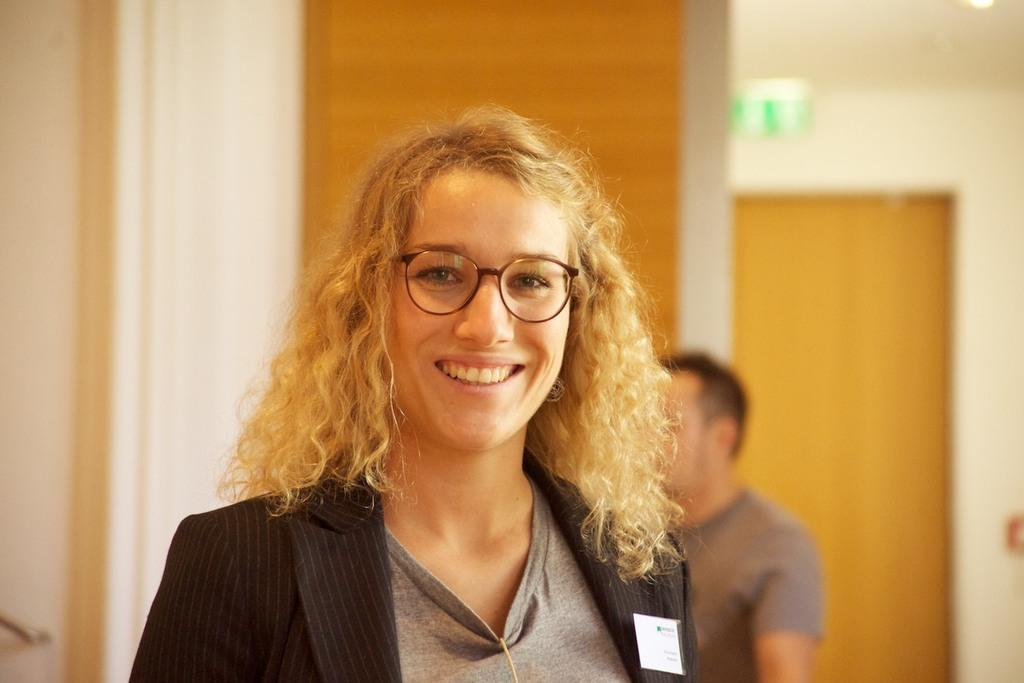What is the main subject of the image? The main subject of the image is a woman. What is the woman wearing in the image? The woman is wearing a black coat. What is the woman's facial expression in the image? The woman is smiling. Can you identify any other person in the image? Yes, there is another person in the image. What grade did the woman receive on her recent test in the image? There is no indication in the image that the woman has recently taken a test or received a grade. What type of crime is being committed in the image? There is no crime being committed in the image; it features a woman and another person. 